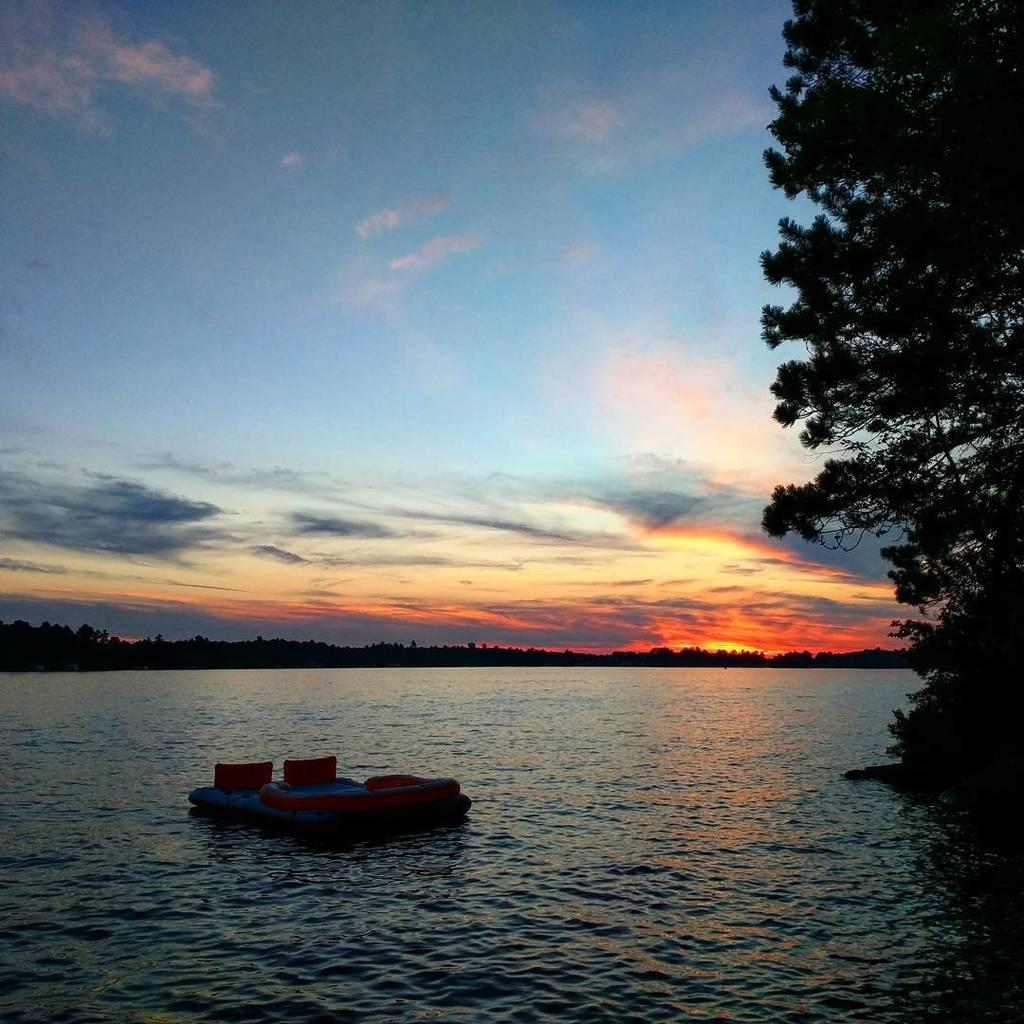What body of water is present in the image? There is a lake in the image. What is on the lake? There is a small boat on the lake. What type of vegetation can be seen in the image? There are trees and bushes in the image. What is the ground cover around the lake? There is grass around the lake. What is the color of the sky in the image? The sky is reddish blue in the image. What type of account is being discussed in the image? There is no account being discussed in the image; it features a lake, a small boat, trees, bushes, grass, and a reddish blue sky. What tool is being used to fix the boat in the image? There is no tool being used to fix the boat in the image; the boat appears to be in good condition. 